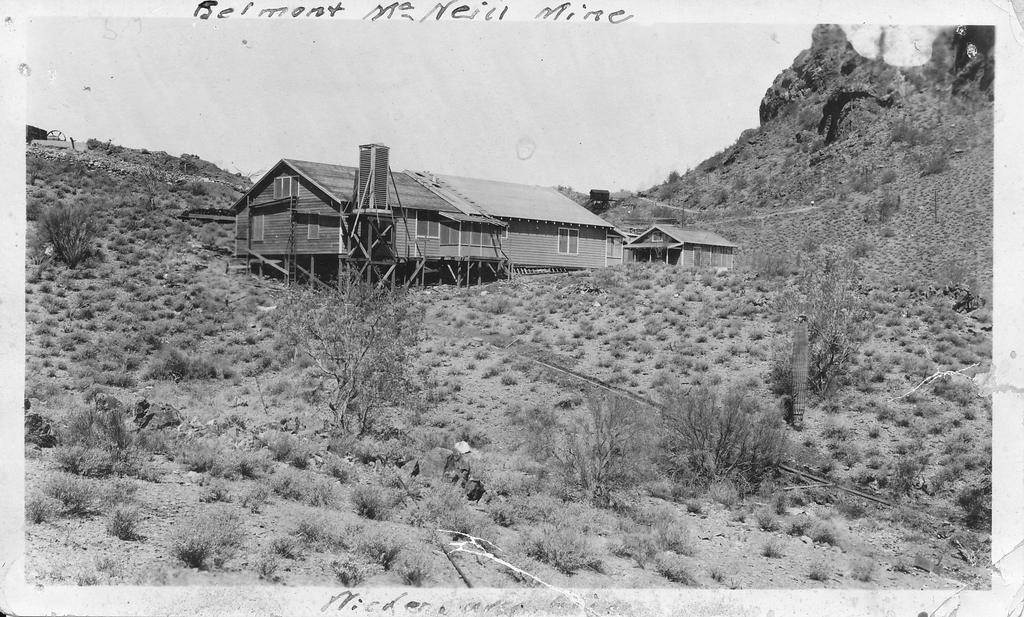What type of vegetation can be seen in the image? There is grass, plants, and trees in the image. What type of structures are present in the image? There are houses in the image. What natural landmarks can be seen in the image? There are mountains in the image. Is there any text present in the image? Yes, there is text in the image. What part of the natural environment is visible in the image? The sky is visible in the image. What type of knot is being tied during the holiday dinner in the image? There is no knot, holiday, or dinner depicted in the image. What type of food is being served at the dinner table in the image? There is no dinner table or food present in the image. 